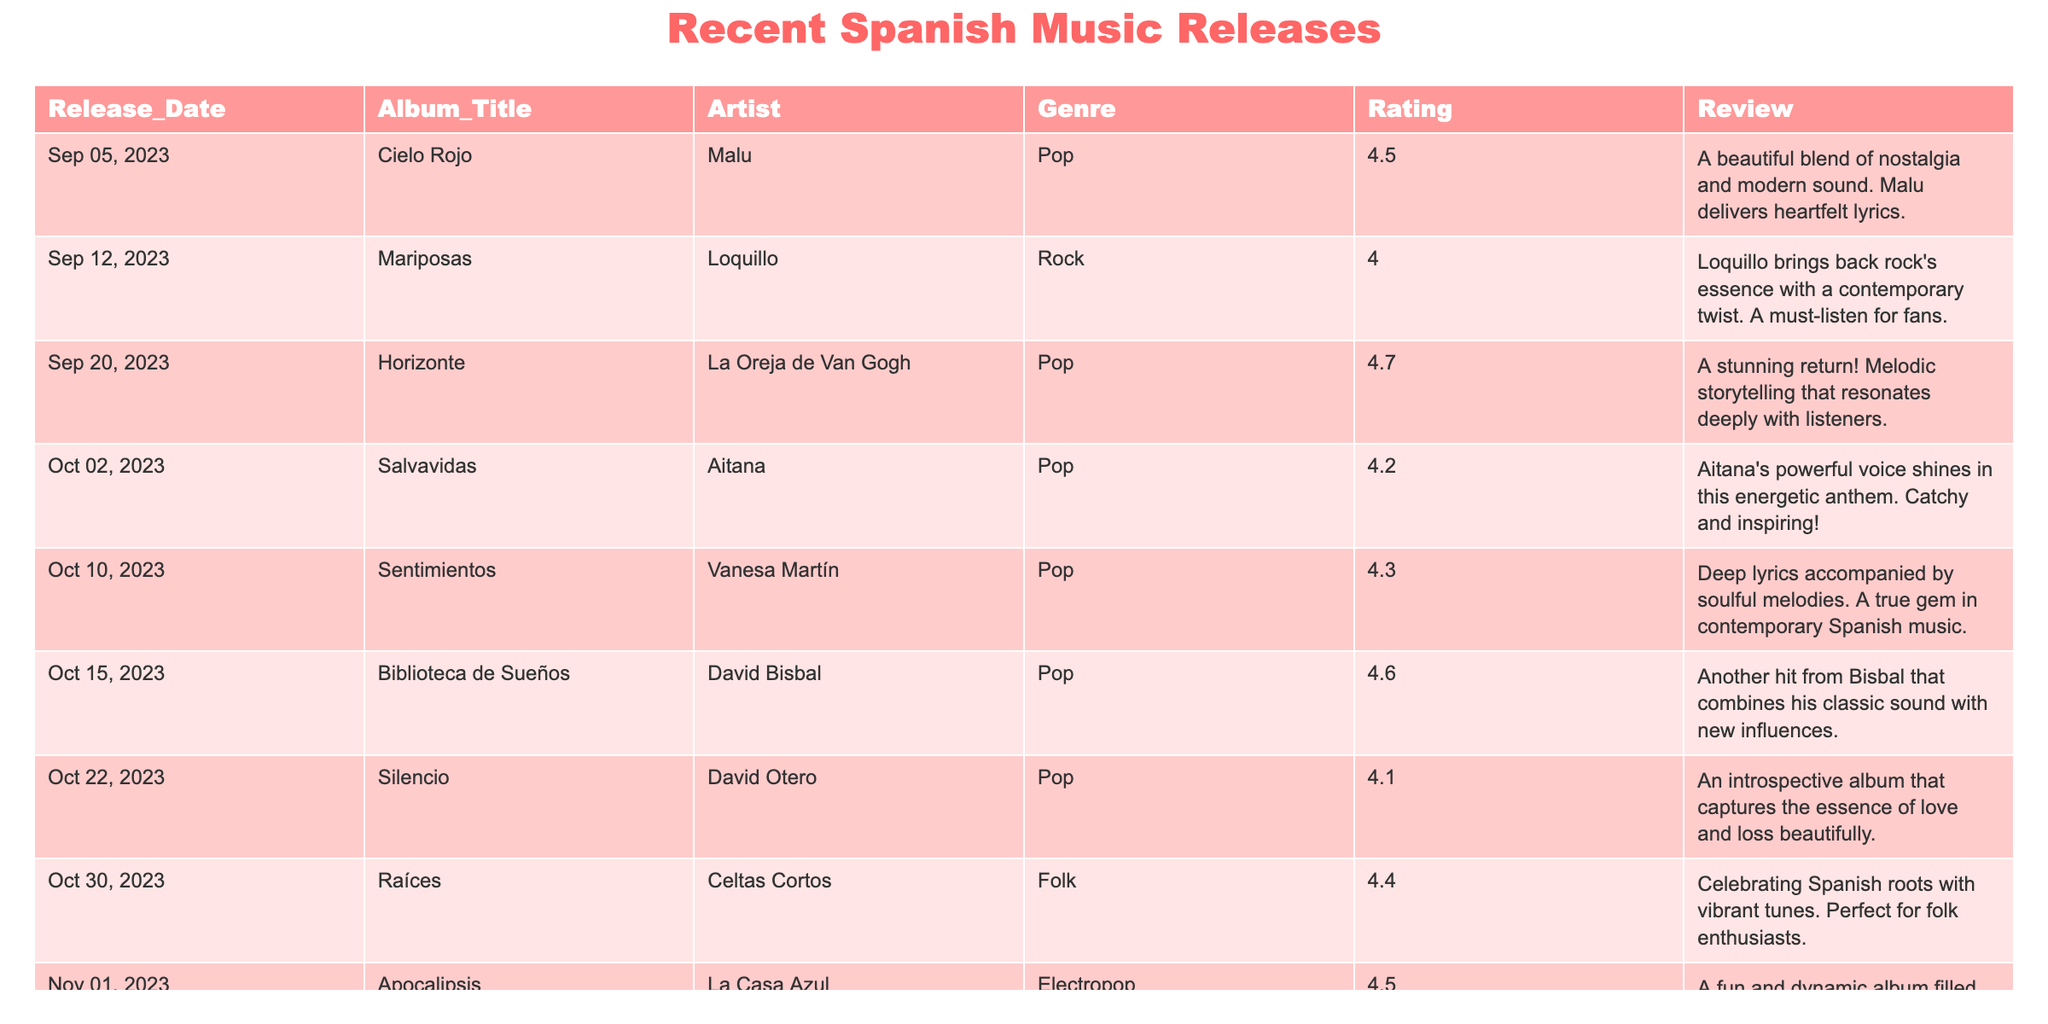What is the highest-rated album in the table? The table lists the ratings for each album. Scanning through the ratings, "Horizonte" by La Oreja de Van Gogh has the highest rating of 4.7.
Answer: 4.7 Which artist has released an album with a rating below 4.2? Looking through the ratings, "Silencio" by David Otero has a rating of 4.1, which is below 4.2.
Answer: Yes What is the average rating of all the albums? To find the average rating, sum all the ratings (4.5 + 4.0 + 4.7 + 4.2 + 4.3 + 4.6 + 4.1 + 4.4 + 4.5) = 39.3. There are 9 albums, so the average rating is 39.3/9 = 4.37.
Answer: 4.37 Which albums were released in October 2023? Filtering the release dates, the albums released in October 2023 are: "Salvavidas" on October 2, "Sentimientos" on October 10, "Biblioteca de Sueños" on October 15, "Silencio" on October 22, and "Apocalipsis" on October 31.
Answer: 5 albums Is "Cielo Rojo" rated higher than "Mariposas"? Comparing the ratings from the table, "Cielo Rojo" by Malu has a rating of 4.5 and "Mariposas" by Loquillo has a rating of 4.0. Since 4.5 is greater than 4.0, the statement is true.
Answer: Yes What is the difference in ratings between "Horizonte" and "Silencio"? "Horizonte" has a rating of 4.7 and "Silencio" has a rating of 4.1. The difference is 4.7 - 4.1 = 0.6.
Answer: 0.6 How many albums are in the Pop genre? Scanning through the genre column, we find the albums: "Cielo Rojo," "Horizonte," "Salvavidas," "Sentimientos," "Biblioteca de Sueños," and "Silencio". Counting these, there are 6 albums in the Pop genre.
Answer: 6 What is the total number of albums listed in the table? Counting the rows of the table, there are 9 entries, each representing a distinct album.
Answer: 9 Which album has a review highlighting both "catchy" and "energetic"? The review for "Salvavidas" by Aitana mentions it is an energetic anthem and catchy, making it the album that meets the criteria.
Answer: Salvavidas 